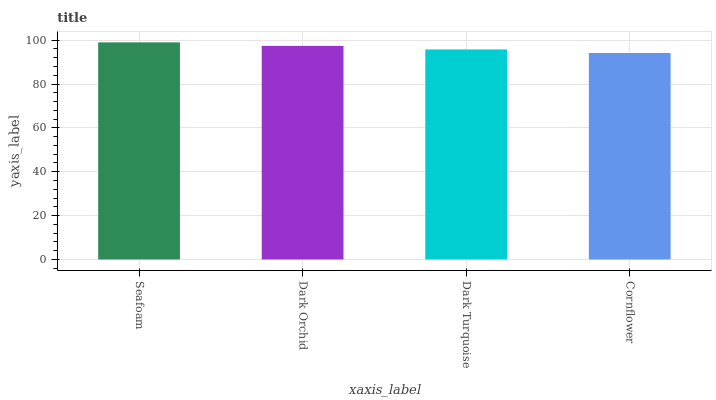Is Cornflower the minimum?
Answer yes or no. Yes. Is Seafoam the maximum?
Answer yes or no. Yes. Is Dark Orchid the minimum?
Answer yes or no. No. Is Dark Orchid the maximum?
Answer yes or no. No. Is Seafoam greater than Dark Orchid?
Answer yes or no. Yes. Is Dark Orchid less than Seafoam?
Answer yes or no. Yes. Is Dark Orchid greater than Seafoam?
Answer yes or no. No. Is Seafoam less than Dark Orchid?
Answer yes or no. No. Is Dark Orchid the high median?
Answer yes or no. Yes. Is Dark Turquoise the low median?
Answer yes or no. Yes. Is Dark Turquoise the high median?
Answer yes or no. No. Is Cornflower the low median?
Answer yes or no. No. 